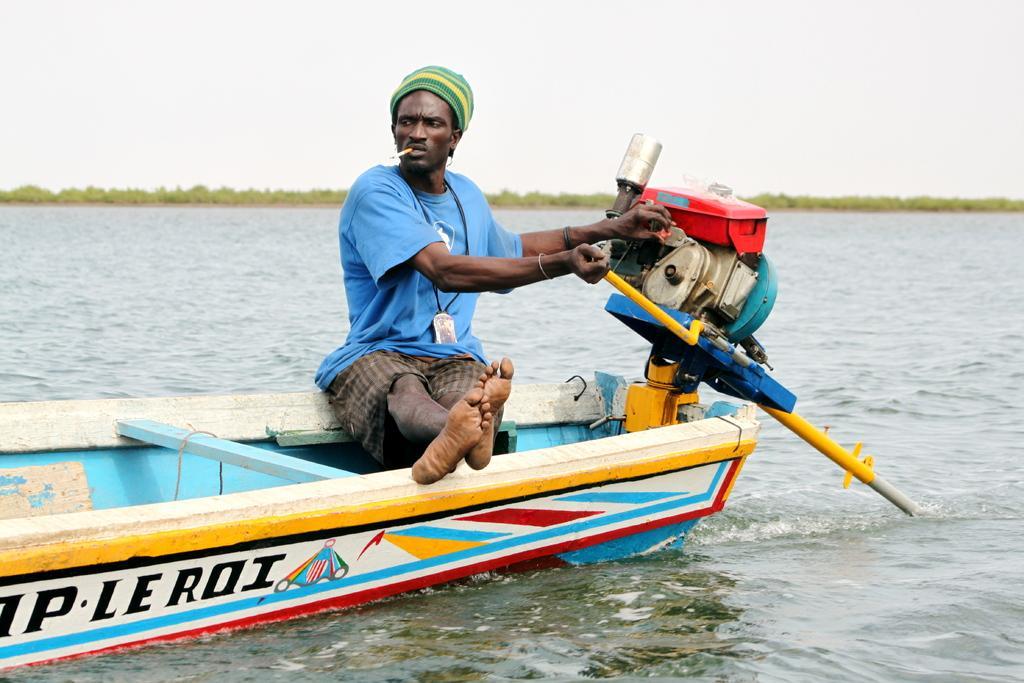Describe this image in one or two sentences. In this picture there is a man sitting on a boat and smoking and holding a machine. We can see water. In the background of the image we can see trees and sky. 